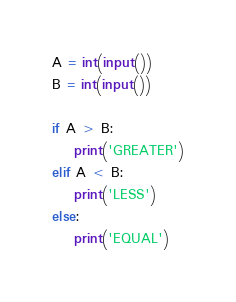<code> <loc_0><loc_0><loc_500><loc_500><_Python_>A = int(input())
B = int(input())

if A > B:
    print('GREATER')
elif A < B:
    print('LESS')
else:
    print('EQUAL')
</code> 